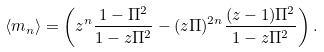<formula> <loc_0><loc_0><loc_500><loc_500>\langle m _ { n } \rangle = \left ( z ^ { n } \frac { 1 - \Pi ^ { 2 } } { 1 - z \Pi ^ { 2 } } - ( z \Pi ) ^ { 2 n } \frac { ( z - 1 ) \Pi ^ { 2 } } { 1 - z \Pi ^ { 2 } } \right ) .</formula> 